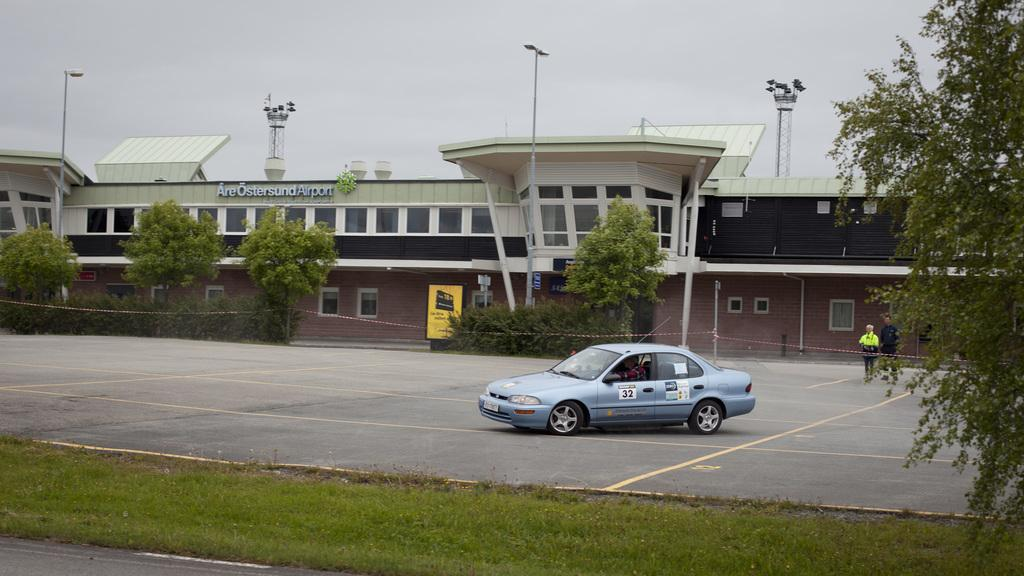What is the main subject of the image? There is a vehicle on the road in the image. Are there any people present in the image? Yes, there are people standing nearby. What type of natural elements can be seen in the image? There are trees visible in the image. What type of man-made structures are present in the image? There are buildings in the image. What type of fruit is hanging from the trees in the image? There is no fruit visible in the image; only trees are present. 